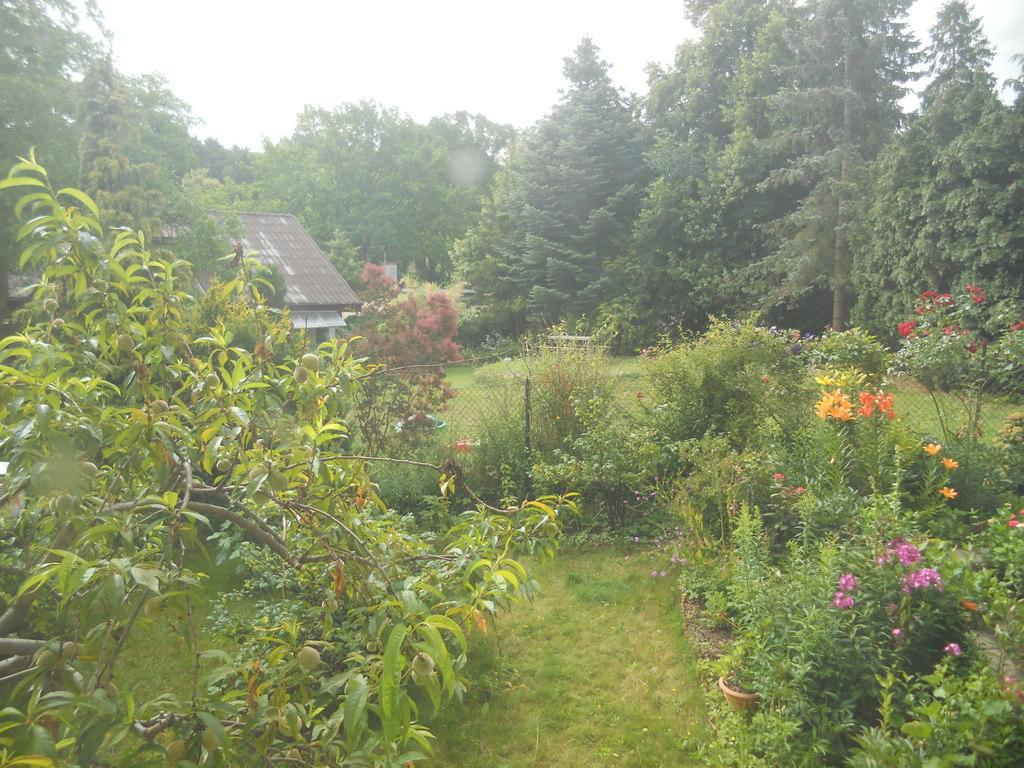What type of vegetation is present in the image? There are many trees and plants in the image. What is the color of the grass at the bottom of the image? The grass at the bottom of the image is green. Where is the house located in the image? The house is to the left of the image. What part of the natural environment is visible in the image? The sky is visible in the image. Can you tell me how many goldfish are swimming in the office in the image? There are no goldfish or office present in the image; it features trees, plants, grass, a house, and the sky. 